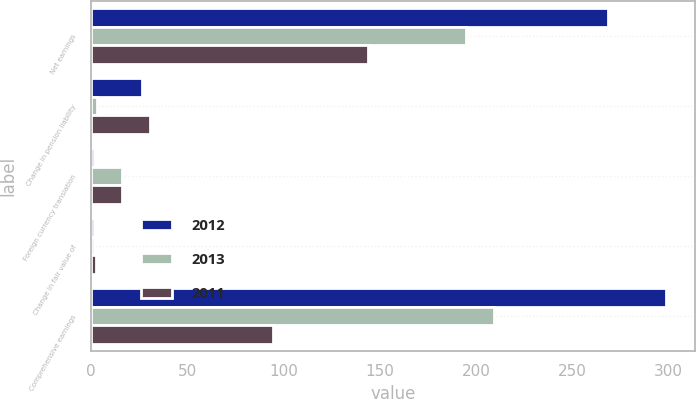Convert chart. <chart><loc_0><loc_0><loc_500><loc_500><stacked_bar_chart><ecel><fcel>Net earnings<fcel>Change in pension liability<fcel>Foreign currency translation<fcel>Change in fair value of<fcel>Comprehensive earnings<nl><fcel>2012<fcel>268.6<fcel>26.8<fcel>1.6<fcel>1.8<fcel>298.8<nl><fcel>2013<fcel>195<fcel>3.4<fcel>16.1<fcel>1.7<fcel>209.4<nl><fcel>2011<fcel>144.1<fcel>30.6<fcel>16.1<fcel>2.7<fcel>94.7<nl></chart> 